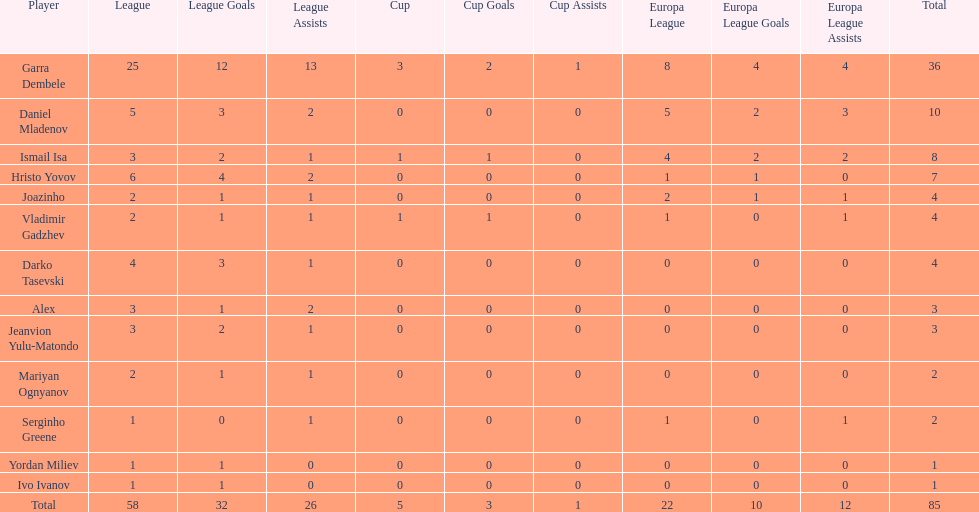Help me parse the entirety of this table. {'header': ['Player', 'League', 'League Goals', 'League Assists', 'Cup', 'Cup Goals', 'Cup Assists', 'Europa League', 'Europa League Goals', 'Europa League Assists', 'Total'], 'rows': [['Garra Dembele', '25', '12', '13', '3', '2', '1', '8', '4', '4', '36'], ['Daniel Mladenov', '5', '3', '2', '0', '0', '0', '5', '2', '3', '10'], ['Ismail Isa', '3', '2', '1', '1', '1', '0', '4', '2', '2', '8'], ['Hristo Yovov', '6', '4', '2', '0', '0', '0', '1', '1', '0', '7'], ['Joazinho', '2', '1', '1', '0', '0', '0', '2', '1', '1', '4'], ['Vladimir Gadzhev', '2', '1', '1', '1', '1', '0', '1', '0', '1', '4'], ['Darko Tasevski', '4', '3', '1', '0', '0', '0', '0', '0', '0', '4'], ['Alex', '3', '1', '2', '0', '0', '0', '0', '0', '0', '3'], ['Jeanvion Yulu-Matondo', '3', '2', '1', '0', '0', '0', '0', '0', '0', '3'], ['Mariyan Ognyanov', '2', '1', '1', '0', '0', '0', '0', '0', '0', '2'], ['Serginho Greene', '1', '0', '1', '0', '0', '0', '1', '0', '1', '2'], ['Yordan Miliev', '1', '1', '0', '0', '0', '0', '0', '0', '0', '1'], ['Ivo Ivanov', '1', '1', '0', '0', '0', '0', '0', '0', '0', '1'], ['Total', '58', '32', '26', '5', '3', '1', '22', '10', '12', '85']]} Is the europa league total or the league total higher? League. 